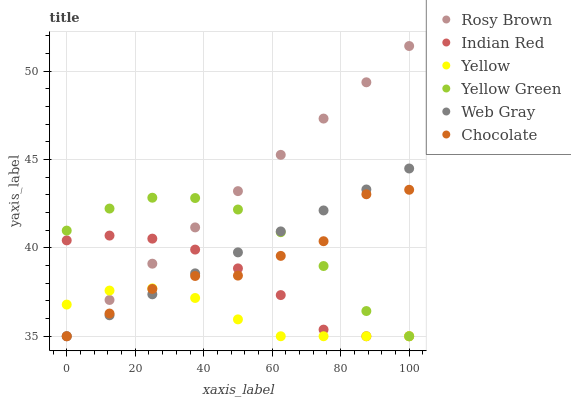Does Yellow have the minimum area under the curve?
Answer yes or no. Yes. Does Rosy Brown have the maximum area under the curve?
Answer yes or no. Yes. Does Yellow Green have the minimum area under the curve?
Answer yes or no. No. Does Yellow Green have the maximum area under the curve?
Answer yes or no. No. Is Rosy Brown the smoothest?
Answer yes or no. Yes. Is Chocolate the roughest?
Answer yes or no. Yes. Is Yellow Green the smoothest?
Answer yes or no. No. Is Yellow Green the roughest?
Answer yes or no. No. Does Web Gray have the lowest value?
Answer yes or no. Yes. Does Rosy Brown have the highest value?
Answer yes or no. Yes. Does Yellow Green have the highest value?
Answer yes or no. No. Does Web Gray intersect Yellow Green?
Answer yes or no. Yes. Is Web Gray less than Yellow Green?
Answer yes or no. No. Is Web Gray greater than Yellow Green?
Answer yes or no. No. 